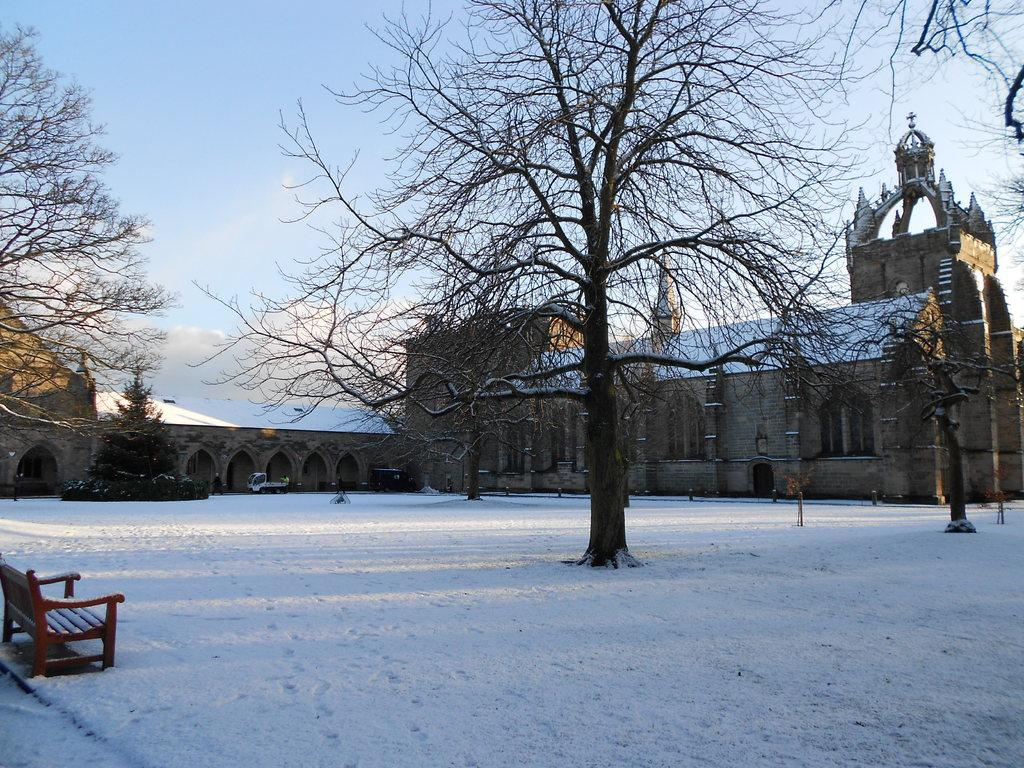What is the main feature of the image? There is a large compartment in the image. What can be seen around the compartment? There are dry trees around the compartment. How does the environment look like around the trees? There is a lot of snow around the trees. Where is the bench located in the image? The bench is on the left side of the image. What type of waste can be seen in the image during the summer season? There is no waste present in the image, and the image does not depict a summer season. 